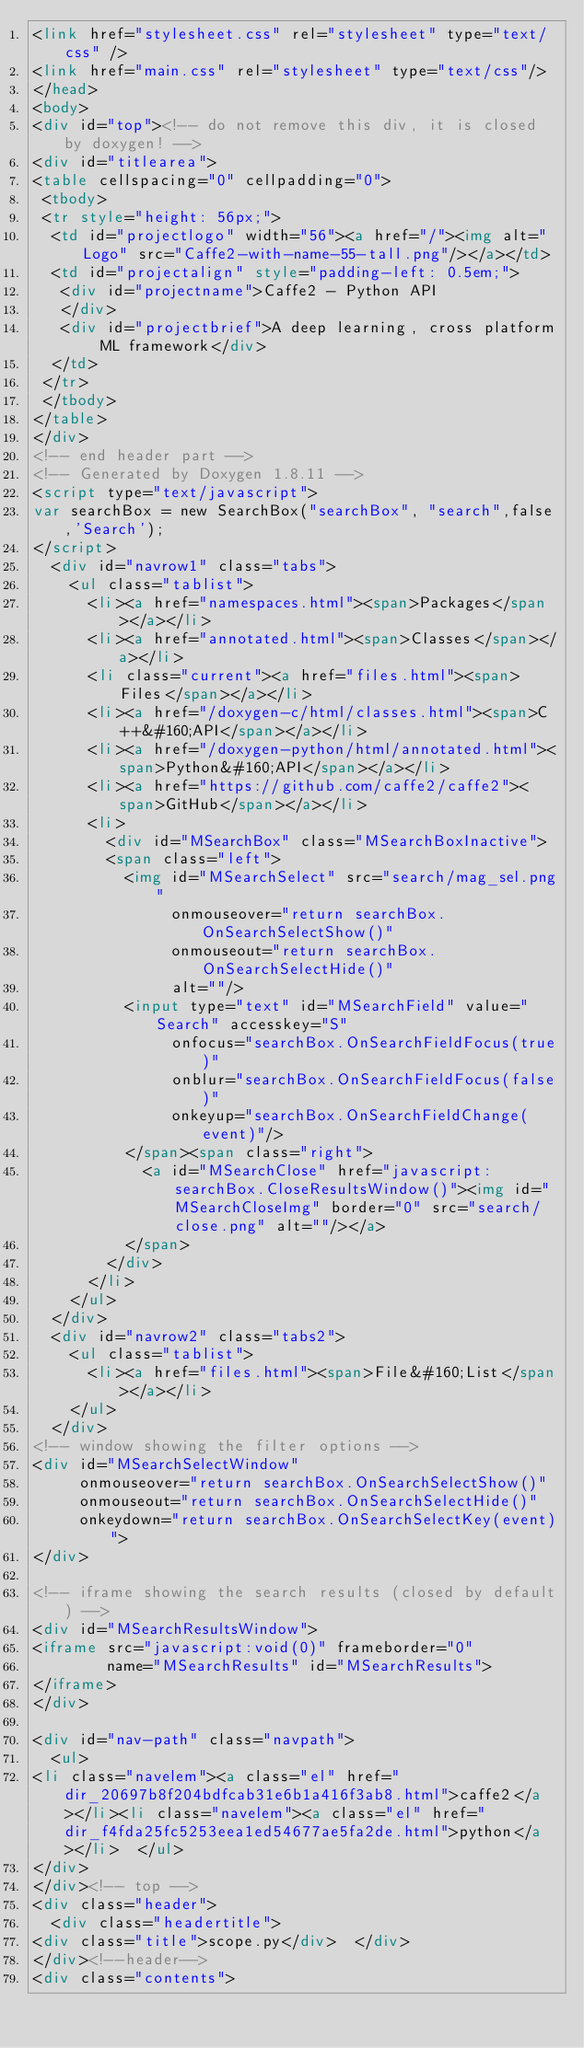<code> <loc_0><loc_0><loc_500><loc_500><_HTML_><link href="stylesheet.css" rel="stylesheet" type="text/css" />
<link href="main.css" rel="stylesheet" type="text/css"/>
</head>
<body>
<div id="top"><!-- do not remove this div, it is closed by doxygen! -->
<div id="titlearea">
<table cellspacing="0" cellpadding="0">
 <tbody>
 <tr style="height: 56px;">
  <td id="projectlogo" width="56"><a href="/"><img alt="Logo" src="Caffe2-with-name-55-tall.png"/></a></td>
  <td id="projectalign" style="padding-left: 0.5em;">
   <div id="projectname">Caffe2 - Python API
   </div>
   <div id="projectbrief">A deep learning, cross platform ML framework</div>
  </td>
 </tr>
 </tbody>
</table>
</div>
<!-- end header part -->
<!-- Generated by Doxygen 1.8.11 -->
<script type="text/javascript">
var searchBox = new SearchBox("searchBox", "search",false,'Search');
</script>
  <div id="navrow1" class="tabs">
    <ul class="tablist">
      <li><a href="namespaces.html"><span>Packages</span></a></li>
      <li><a href="annotated.html"><span>Classes</span></a></li>
      <li class="current"><a href="files.html"><span>Files</span></a></li>
      <li><a href="/doxygen-c/html/classes.html"><span>C++&#160;API</span></a></li>
      <li><a href="/doxygen-python/html/annotated.html"><span>Python&#160;API</span></a></li>
      <li><a href="https://github.com/caffe2/caffe2"><span>GitHub</span></a></li>
      <li>
        <div id="MSearchBox" class="MSearchBoxInactive">
        <span class="left">
          <img id="MSearchSelect" src="search/mag_sel.png"
               onmouseover="return searchBox.OnSearchSelectShow()"
               onmouseout="return searchBox.OnSearchSelectHide()"
               alt=""/>
          <input type="text" id="MSearchField" value="Search" accesskey="S"
               onfocus="searchBox.OnSearchFieldFocus(true)" 
               onblur="searchBox.OnSearchFieldFocus(false)" 
               onkeyup="searchBox.OnSearchFieldChange(event)"/>
          </span><span class="right">
            <a id="MSearchClose" href="javascript:searchBox.CloseResultsWindow()"><img id="MSearchCloseImg" border="0" src="search/close.png" alt=""/></a>
          </span>
        </div>
      </li>
    </ul>
  </div>
  <div id="navrow2" class="tabs2">
    <ul class="tablist">
      <li><a href="files.html"><span>File&#160;List</span></a></li>
    </ul>
  </div>
<!-- window showing the filter options -->
<div id="MSearchSelectWindow"
     onmouseover="return searchBox.OnSearchSelectShow()"
     onmouseout="return searchBox.OnSearchSelectHide()"
     onkeydown="return searchBox.OnSearchSelectKey(event)">
</div>

<!-- iframe showing the search results (closed by default) -->
<div id="MSearchResultsWindow">
<iframe src="javascript:void(0)" frameborder="0" 
        name="MSearchResults" id="MSearchResults">
</iframe>
</div>

<div id="nav-path" class="navpath">
  <ul>
<li class="navelem"><a class="el" href="dir_20697b8f204bdfcab31e6b1a416f3ab8.html">caffe2</a></li><li class="navelem"><a class="el" href="dir_f4fda25fc5253eea1ed54677ae5fa2de.html">python</a></li>  </ul>
</div>
</div><!-- top -->
<div class="header">
  <div class="headertitle">
<div class="title">scope.py</div>  </div>
</div><!--header-->
<div class="contents"></code> 